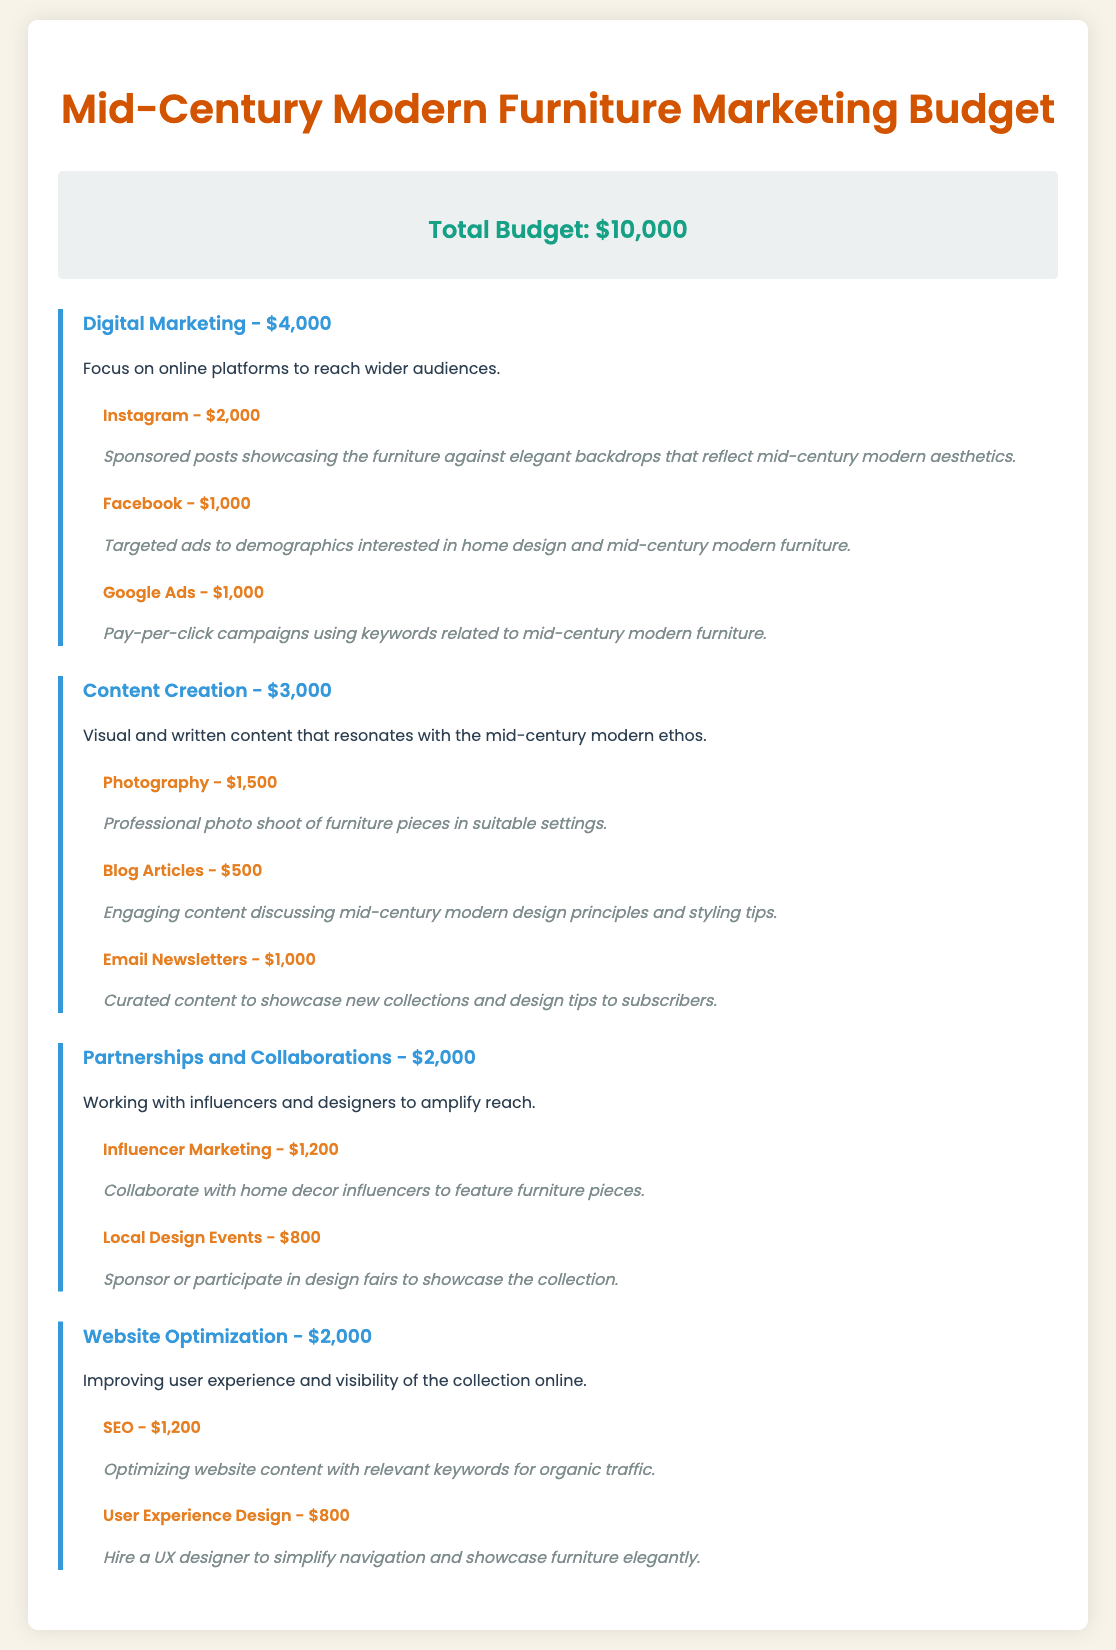What is the total budget? The total budget is stated clearly at the beginning of the document, which is $10,000.
Answer: $10,000 How much is allocated for digital marketing? The document specifies $4,000 is allocated to digital marketing efforts.
Answer: $4,000 What marketing strategy costs the most within content creation? The most expensive strategy within content creation is professional photography, which costs $1,500.
Answer: $1,500 How much funding is designated for influencer marketing? The document mentions that influencer marketing is allocated $1,200.
Answer: $1,200 What is the budget for SEO? The budget for SEO, as detailed in the website optimization section, is $1,200.
Answer: $1,200 Which social media platform has the highest allocation for marketing? The highest allocation for marketing among social media platforms is Instagram, with $2,000.
Answer: Instagram What is the total budget for partnerships and collaborations? The document indicates that the total budget for partnerships and collaborations is $2,000.
Answer: $2,000 How much is allocated for blog articles? According to the content creation section, $500 is allocated for blog articles.
Answer: $500 What is the budget for user experience design? The budget allocated for user experience design is specified as $800 in the document.
Answer: $800 